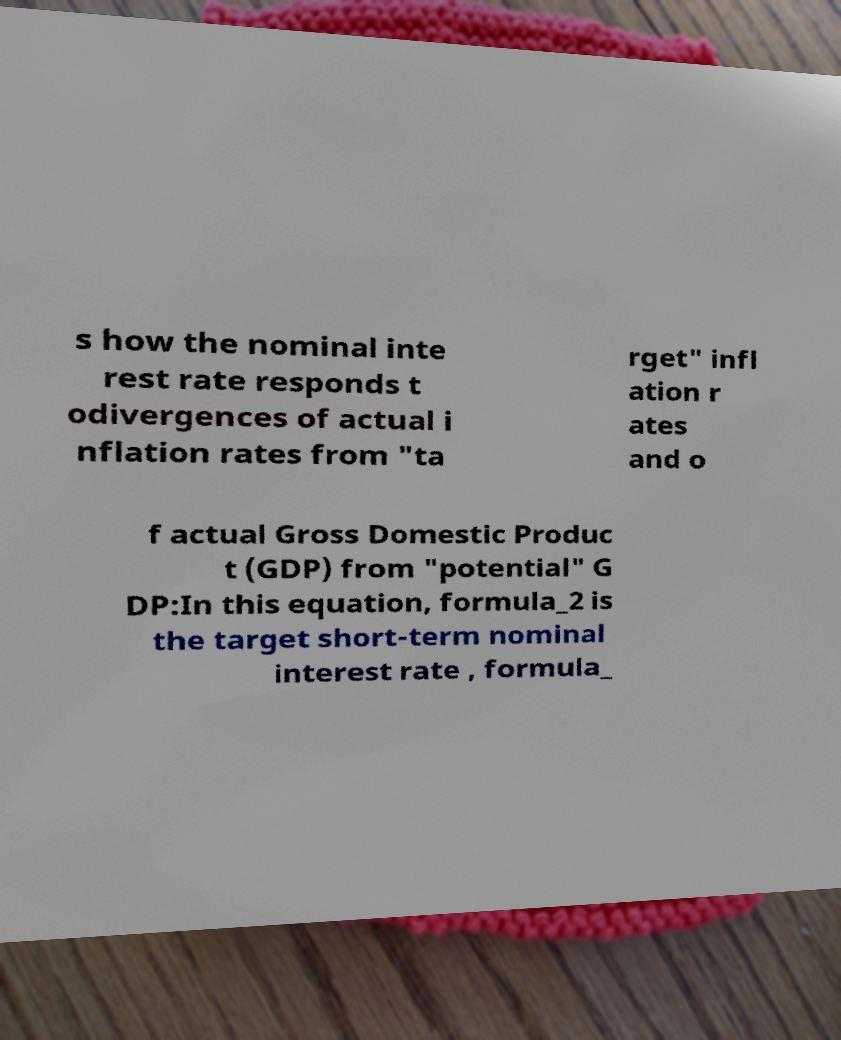For documentation purposes, I need the text within this image transcribed. Could you provide that? s how the nominal inte rest rate responds t odivergences of actual i nflation rates from "ta rget" infl ation r ates and o f actual Gross Domestic Produc t (GDP) from "potential" G DP:In this equation, formula_2 is the target short-term nominal interest rate , formula_ 